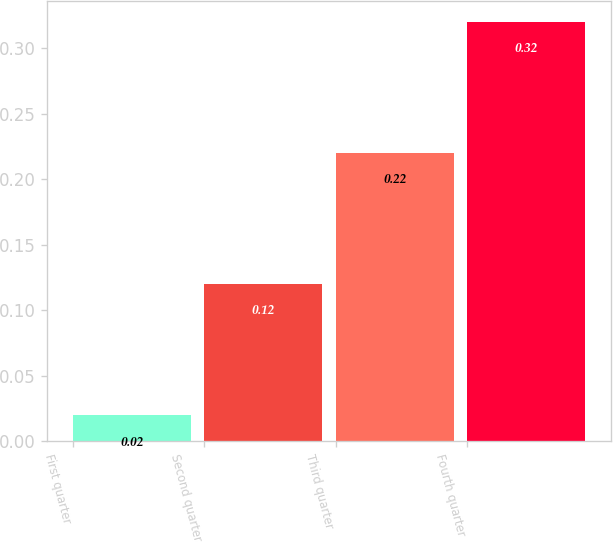<chart> <loc_0><loc_0><loc_500><loc_500><bar_chart><fcel>First quarter<fcel>Second quarter<fcel>Third quarter<fcel>Fourth quarter<nl><fcel>0.02<fcel>0.12<fcel>0.22<fcel>0.32<nl></chart> 